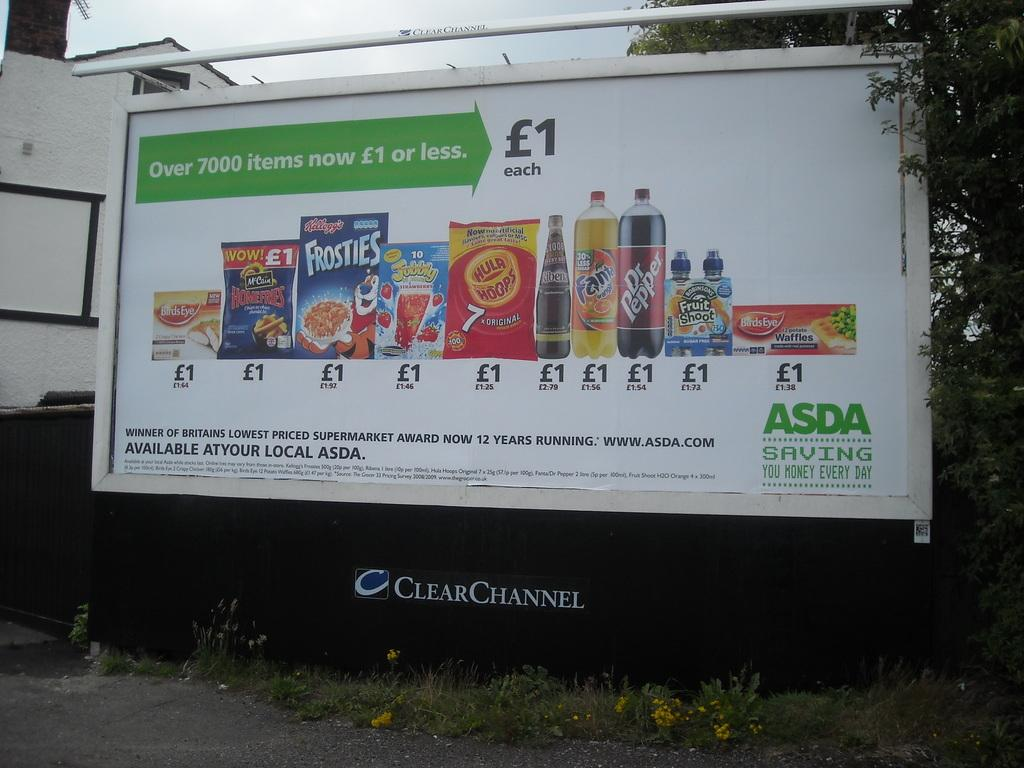<image>
Describe the image concisely. A big advertisement for different food items like Dr. Pepper. 